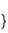<code> <loc_0><loc_0><loc_500><loc_500><_Scala_>}
</code> 